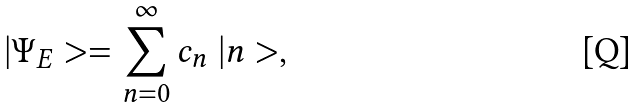Convert formula to latex. <formula><loc_0><loc_0><loc_500><loc_500>| \Psi _ { E } > = \sum _ { n = 0 } ^ { \infty } c _ { n } \ | n > ,</formula> 